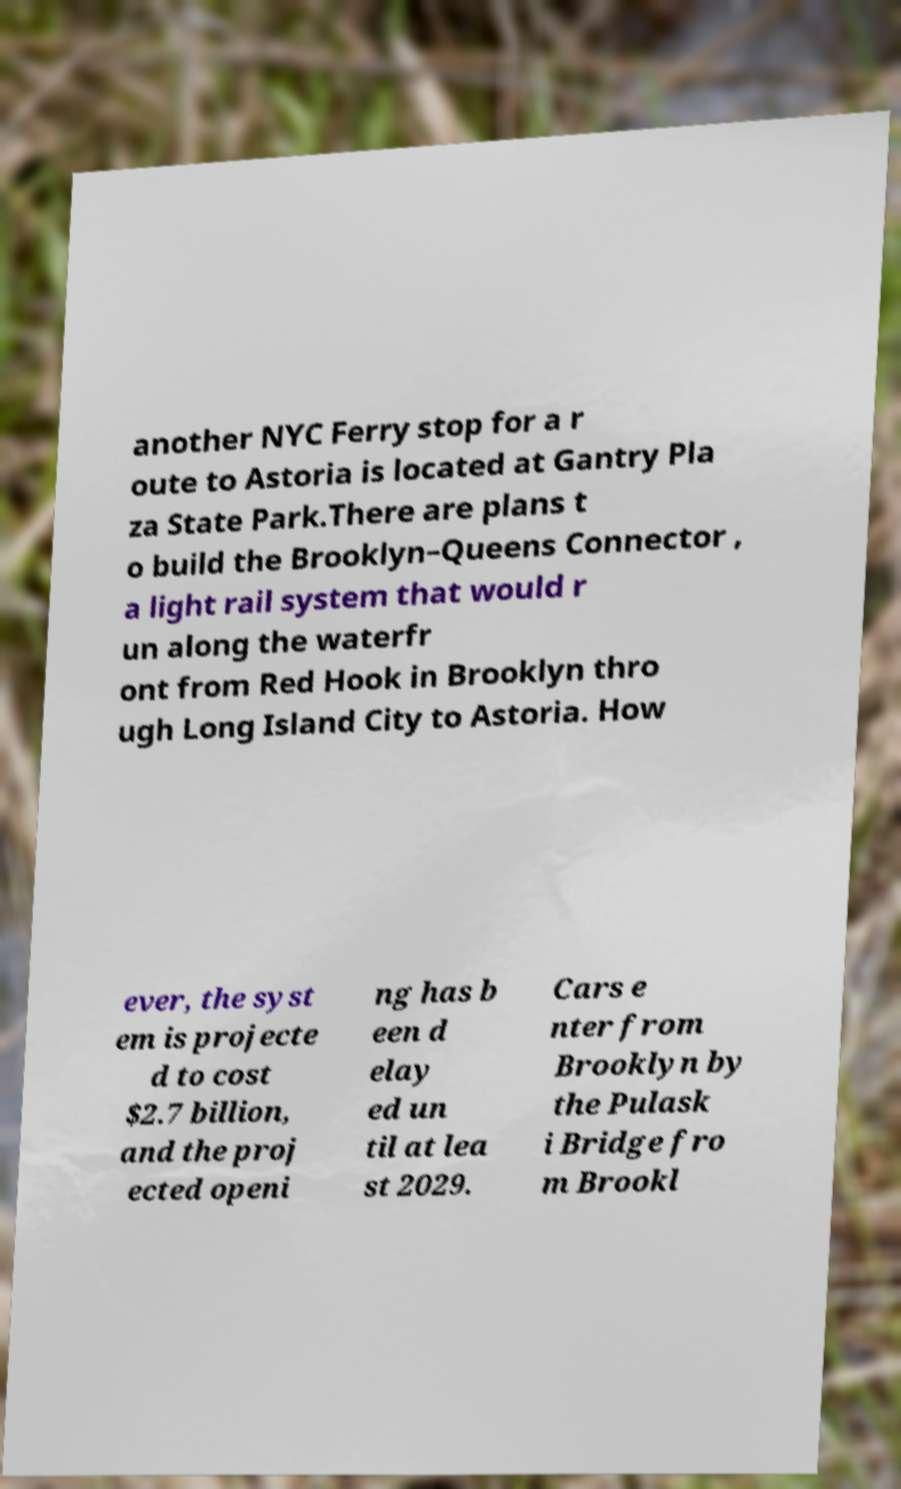Please read and relay the text visible in this image. What does it say? another NYC Ferry stop for a r oute to Astoria is located at Gantry Pla za State Park.There are plans t o build the Brooklyn–Queens Connector , a light rail system that would r un along the waterfr ont from Red Hook in Brooklyn thro ugh Long Island City to Astoria. How ever, the syst em is projecte d to cost $2.7 billion, and the proj ected openi ng has b een d elay ed un til at lea st 2029. Cars e nter from Brooklyn by the Pulask i Bridge fro m Brookl 